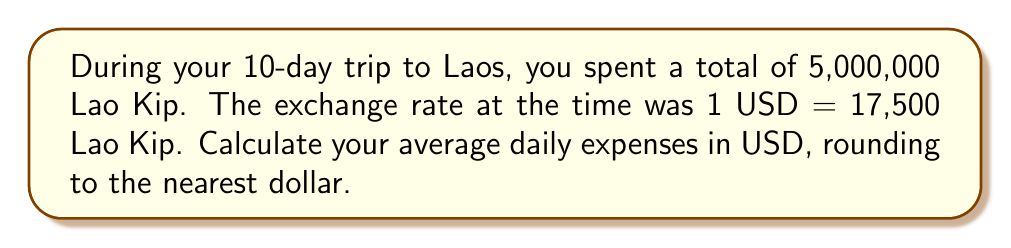Can you solve this math problem? Let's break this down step-by-step:

1. First, we need to convert the total spent in Lao Kip to USD:
   $$\text{Total USD} = \frac{\text{Total Lao Kip}}{\text{Exchange Rate}}$$
   $$\text{Total USD} = \frac{5,000,000}{17,500} = 285.71 \text{ USD}$$

2. Now that we have the total spent in USD, we need to divide it by the number of days to get the average daily expense:
   $$\text{Average Daily Expense} = \frac{\text{Total USD}}{\text{Number of Days}}$$
   $$\text{Average Daily Expense} = \frac{285.71}{10} = 28.571 \text{ USD}$$

3. Rounding to the nearest dollar:
   $$28.571 \text{ USD} \approx 29 \text{ USD}$$
Answer: $29 